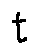<formula> <loc_0><loc_0><loc_500><loc_500>t</formula> 